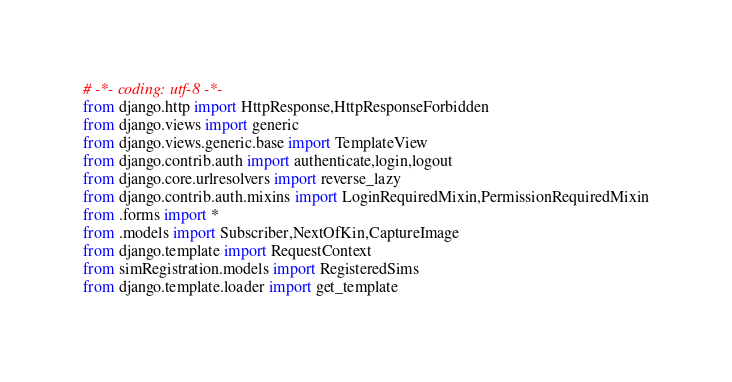Convert code to text. <code><loc_0><loc_0><loc_500><loc_500><_Python_># -*- coding: utf-8 -*-
from django.http import HttpResponse,HttpResponseForbidden
from django.views import generic
from django.views.generic.base import TemplateView
from django.contrib.auth import authenticate,login,logout
from django.core.urlresolvers import reverse_lazy
from django.contrib.auth.mixins import LoginRequiredMixin,PermissionRequiredMixin
from .forms import *
from .models import Subscriber,NextOfKin,CaptureImage
from django.template import RequestContext
from simRegistration.models import RegisteredSims
from django.template.loader import get_template</code> 